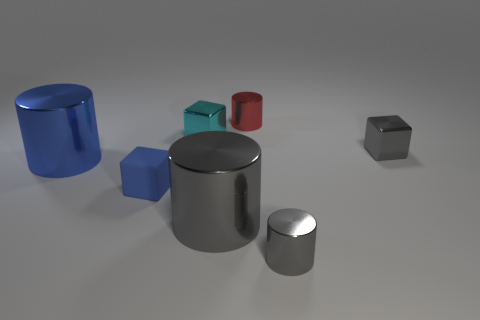What number of other blue matte blocks are the same size as the blue cube? Upon reviewing the image, it appears there are no other blue matte blocks of the same size as the blue cube. The blue cylinder and the smaller blue block are of different shapes and sizes. 